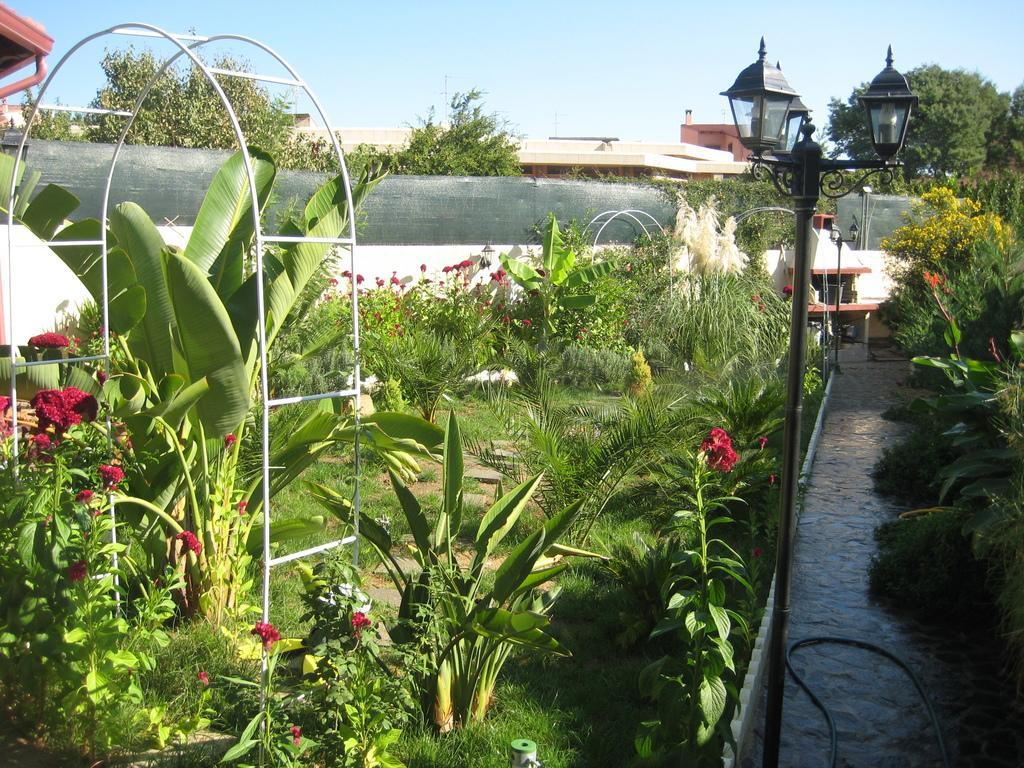Can you describe this image briefly? It is looking like a garden. On the right side I can see a path, on both sides of this there are some plants in green color along with some flowers and also there is a pole. At the top of it I can see the lights. On the left side there is a metal stand in the garden. In the background I can see a wall and building. On the top of the image I can see the sky. 